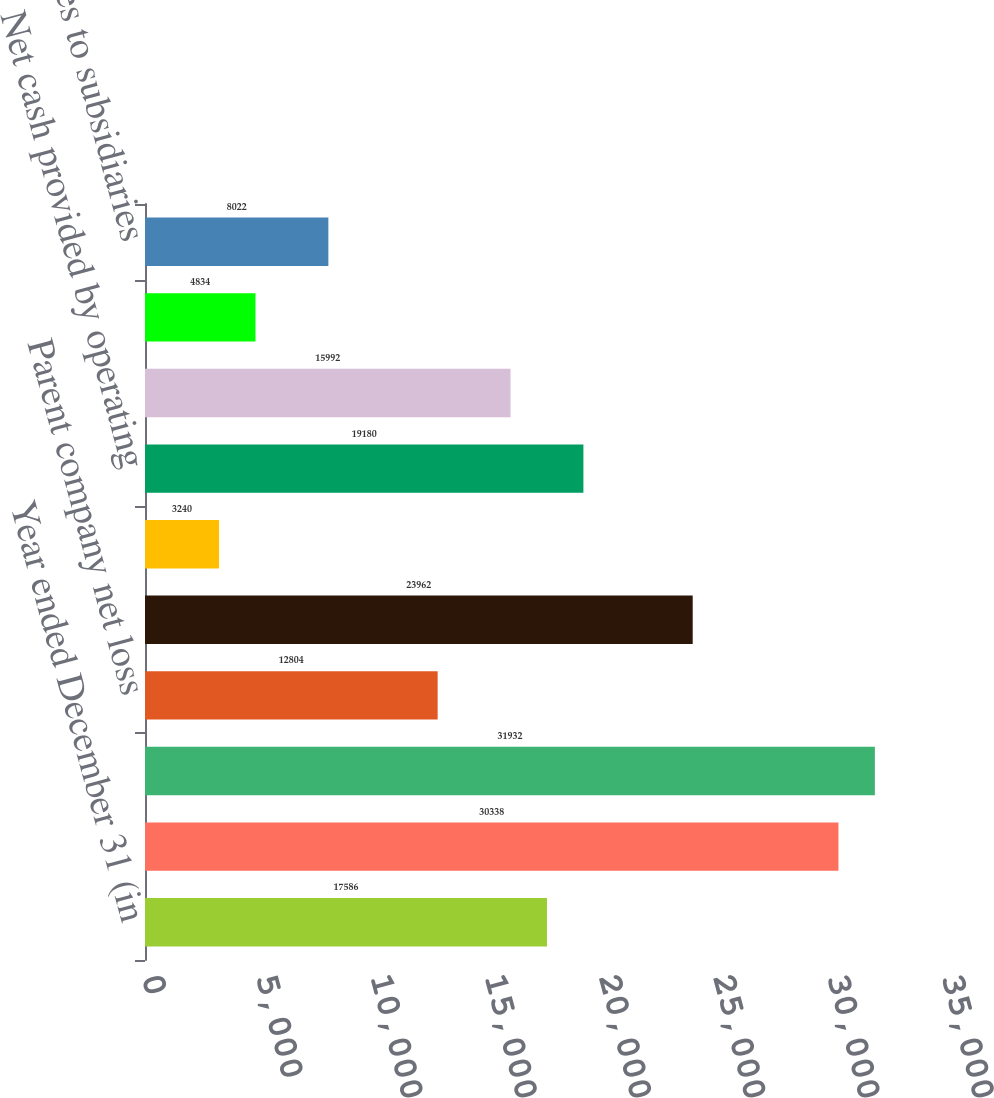Convert chart to OTSL. <chart><loc_0><loc_0><loc_500><loc_500><bar_chart><fcel>Year ended December 31 (in<fcel>Net income<fcel>Less Net income of<fcel>Parent company net loss<fcel>Add Cash dividends from<fcel>Other net<fcel>Net cash provided by operating<fcel>Deposits with banking<fcel>Loans<fcel>Advances to subsidiaries<nl><fcel>17586<fcel>30338<fcel>31932<fcel>12804<fcel>23962<fcel>3240<fcel>19180<fcel>15992<fcel>4834<fcel>8022<nl></chart> 